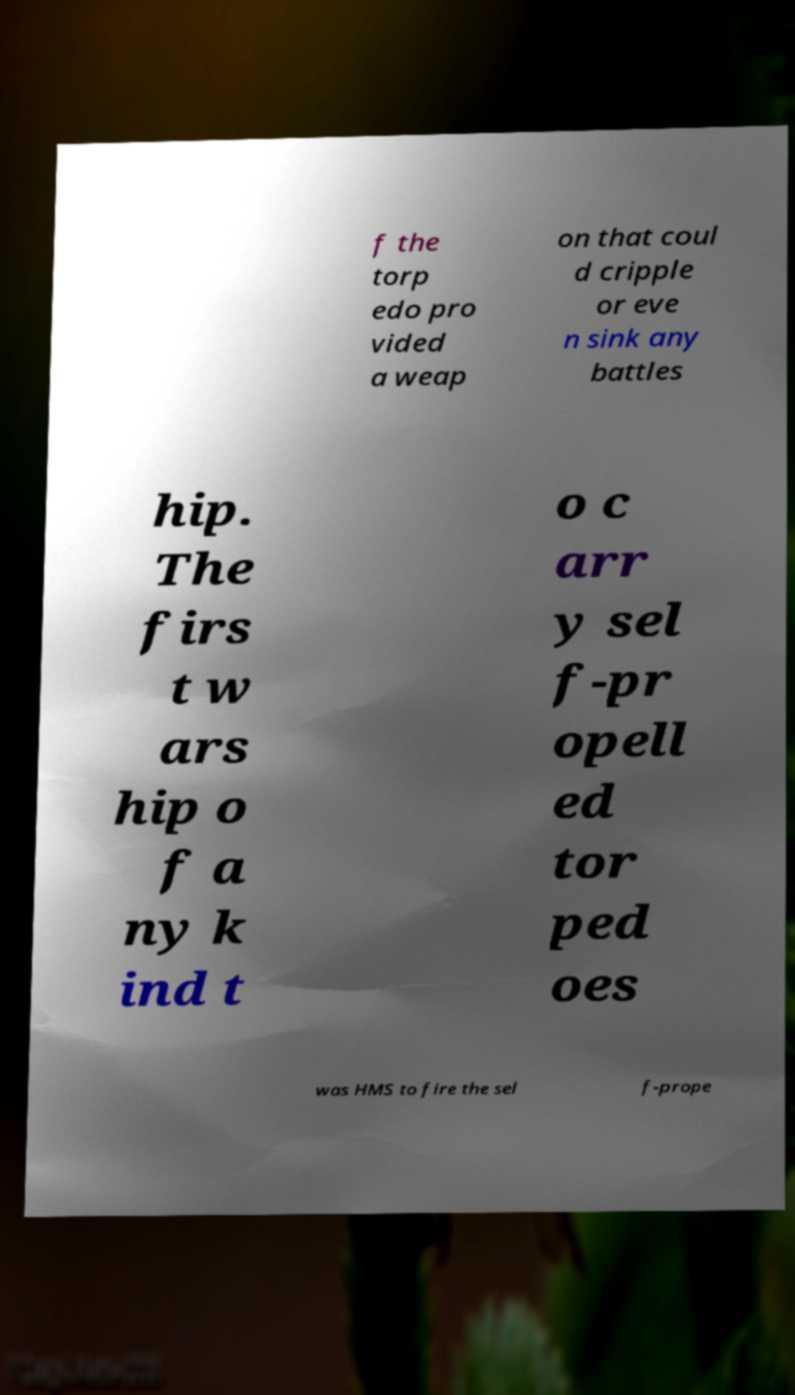What messages or text are displayed in this image? I need them in a readable, typed format. f the torp edo pro vided a weap on that coul d cripple or eve n sink any battles hip. The firs t w ars hip o f a ny k ind t o c arr y sel f-pr opell ed tor ped oes was HMS to fire the sel f-prope 